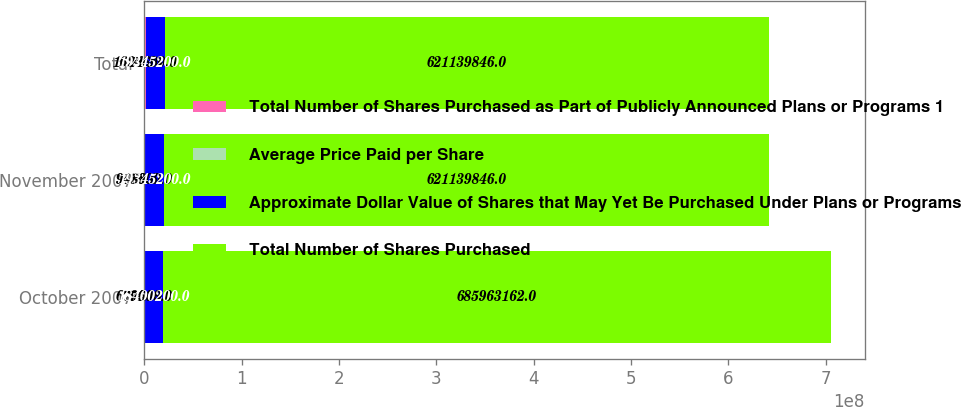<chart> <loc_0><loc_0><loc_500><loc_500><stacked_bar_chart><ecel><fcel>October 2007<fcel>November 2007<fcel>Total<nl><fcel>Total Number of Shares Purchased as Part of Publicly Announced Plans or Programs 1<fcel>679600<fcel>945000<fcel>1.6246e+06<nl><fcel>Average Price Paid per Share<fcel>74.89<fcel>68.6<fcel>71.23<nl><fcel>Approximate Dollar Value of Shares that May Yet Be Purchased Under Plans or Programs<fcel>1.84002e+07<fcel>1.93452e+07<fcel>1.93452e+07<nl><fcel>Total Number of Shares Purchased<fcel>6.85963e+08<fcel>6.2114e+08<fcel>6.2114e+08<nl></chart> 